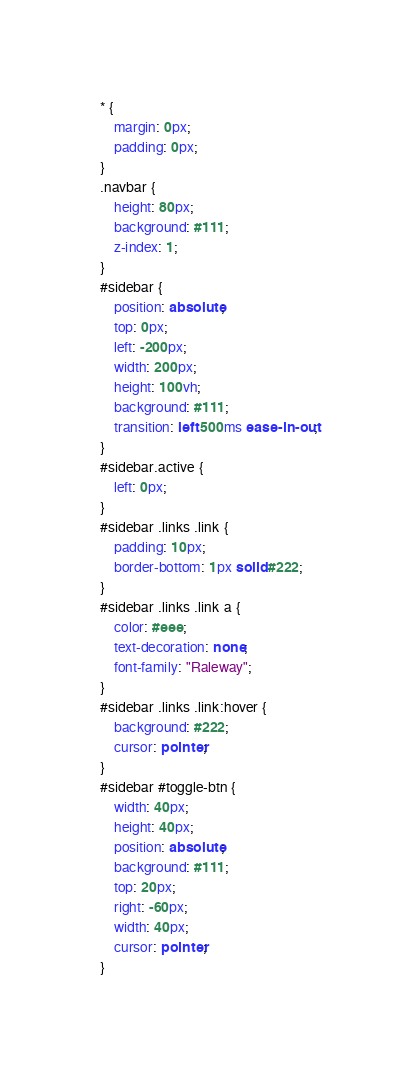Convert code to text. <code><loc_0><loc_0><loc_500><loc_500><_CSS_>* {
	margin: 0px;
	padding: 0px;
}
.navbar {
	height: 80px;
	background: #111;
	z-index: 1;
}
#sidebar {
	position: absolute;
	top: 0px;
	left: -200px;
	width: 200px;
	height: 100vh;
	background: #111;
	transition: left 500ms ease-in-out;
}
#sidebar.active {
	left: 0px;
}
#sidebar .links .link {
	padding: 10px;
	border-bottom: 1px solid #222;
}
#sidebar .links .link a {
	color: #eee;
	text-decoration: none;
	font-family: "Raleway";
}
#sidebar .links .link:hover {
	background: #222;
	cursor: pointer;
}
#sidebar #toggle-btn {
	width: 40px;
	height: 40px;
	position: absolute;
	background: #111;
	top: 20px;
	right: -60px;
	width: 40px;
	cursor: pointer;
}</code> 